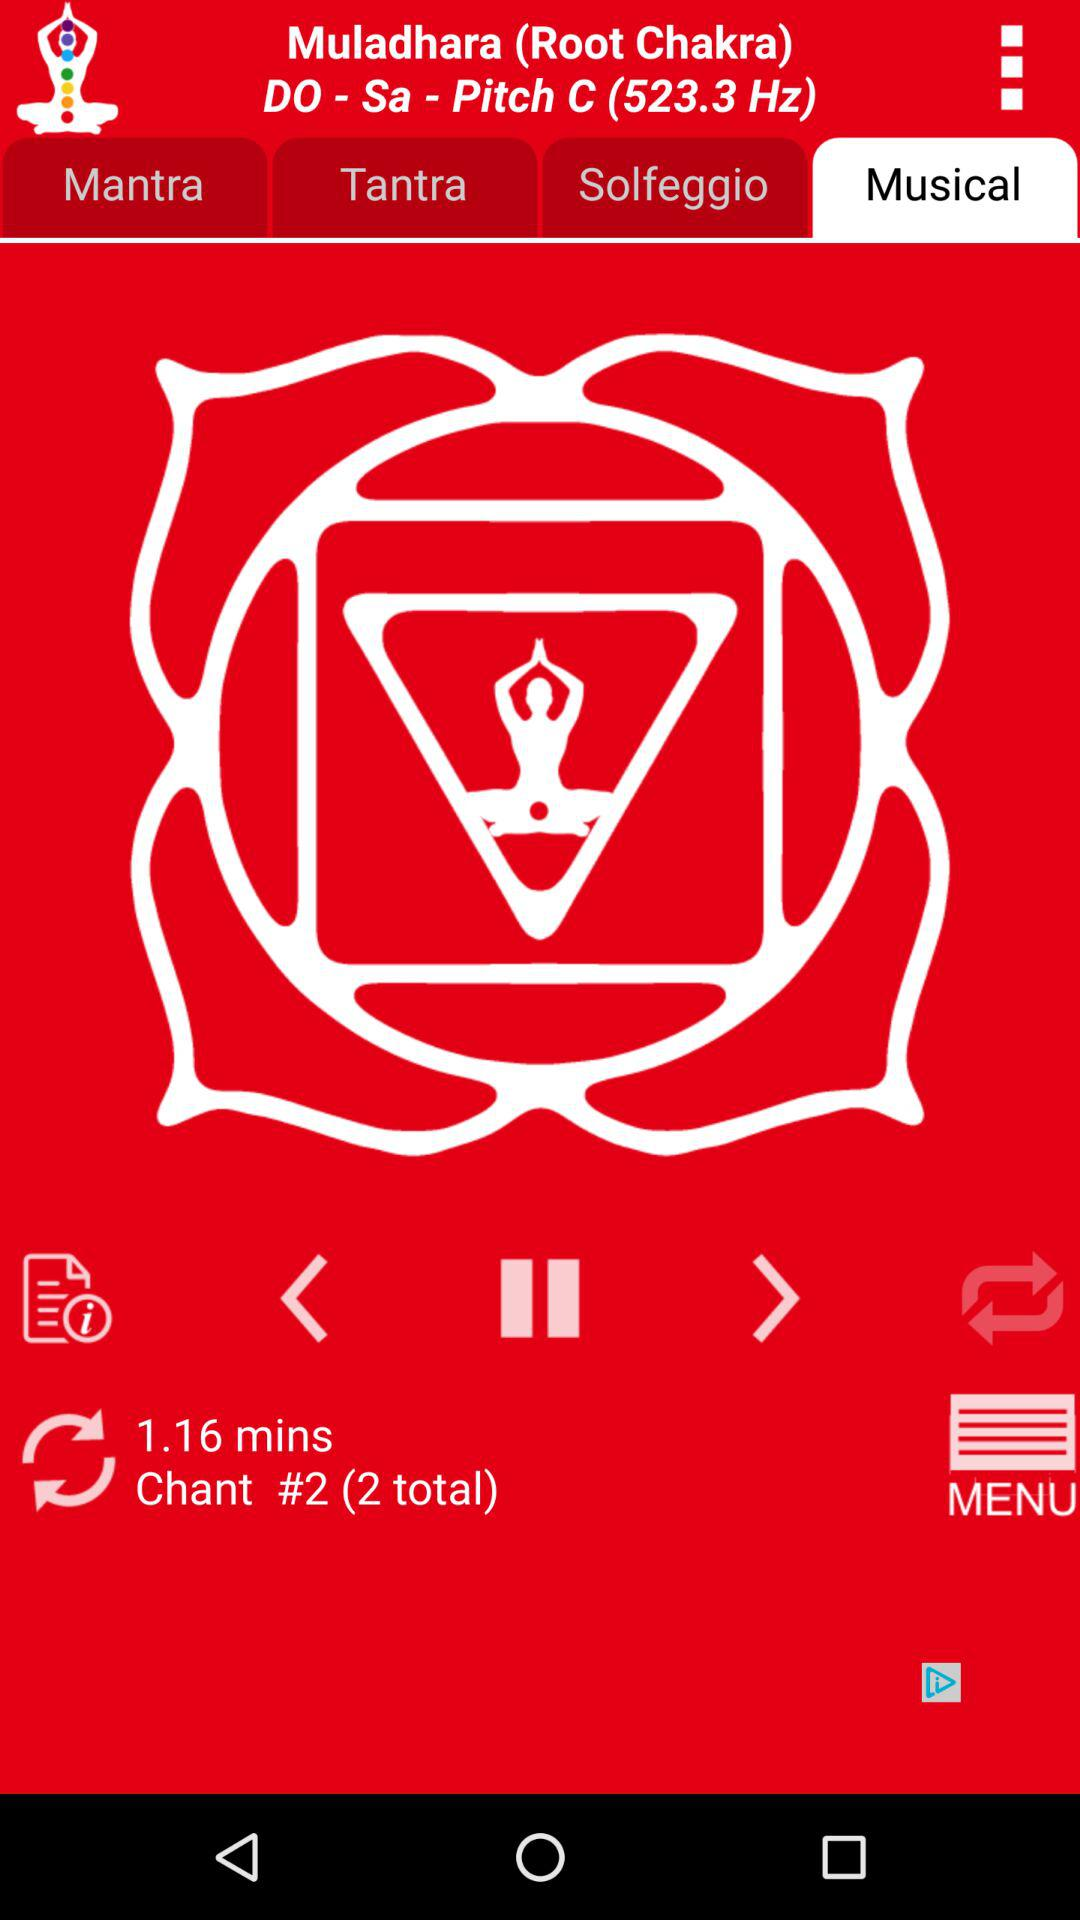What is the pitch shown on the screen? The pitch shown on the screen is 523.3 Hz. 